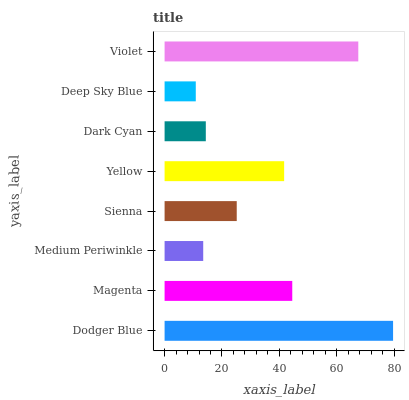Is Deep Sky Blue the minimum?
Answer yes or no. Yes. Is Dodger Blue the maximum?
Answer yes or no. Yes. Is Magenta the minimum?
Answer yes or no. No. Is Magenta the maximum?
Answer yes or no. No. Is Dodger Blue greater than Magenta?
Answer yes or no. Yes. Is Magenta less than Dodger Blue?
Answer yes or no. Yes. Is Magenta greater than Dodger Blue?
Answer yes or no. No. Is Dodger Blue less than Magenta?
Answer yes or no. No. Is Yellow the high median?
Answer yes or no. Yes. Is Sienna the low median?
Answer yes or no. Yes. Is Medium Periwinkle the high median?
Answer yes or no. No. Is Magenta the low median?
Answer yes or no. No. 